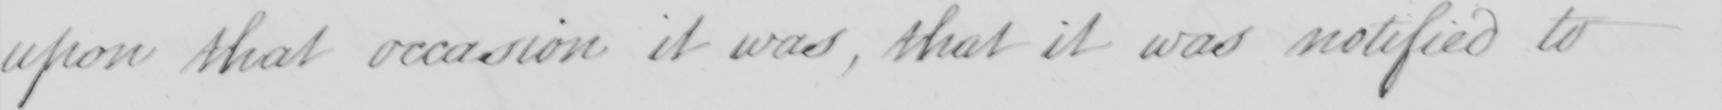Can you tell me what this handwritten text says? upon that occasion it was, that it was notified to 